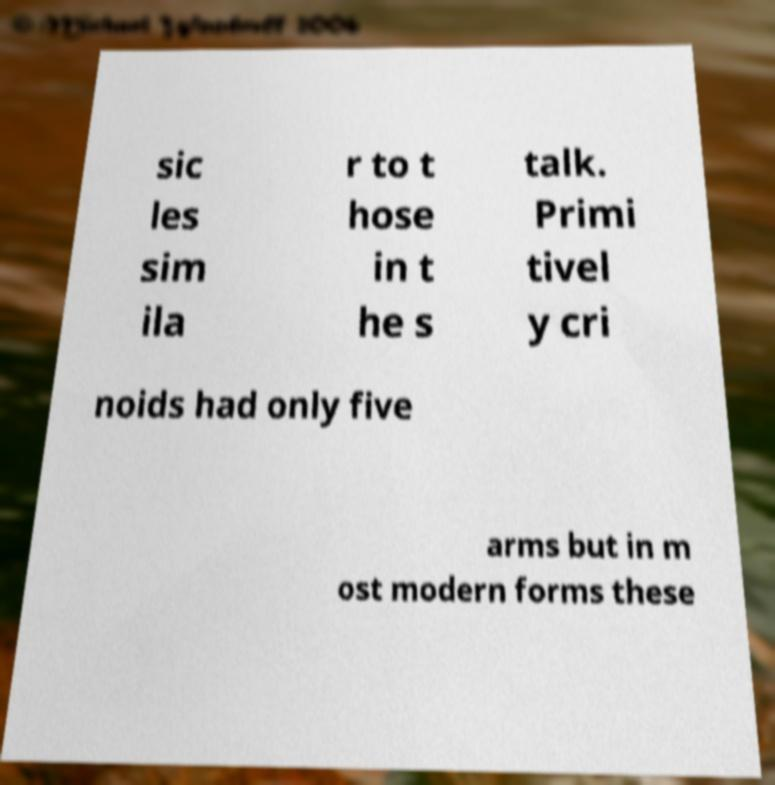For documentation purposes, I need the text within this image transcribed. Could you provide that? sic les sim ila r to t hose in t he s talk. Primi tivel y cri noids had only five arms but in m ost modern forms these 